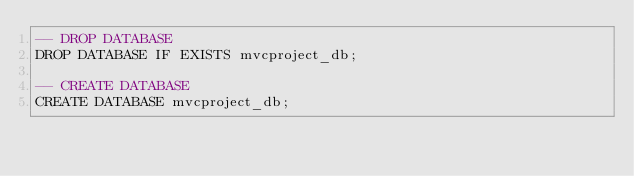<code> <loc_0><loc_0><loc_500><loc_500><_SQL_>-- DROP DATABASE
DROP DATABASE IF EXISTS mvcproject_db;

-- CREATE DATABASE
CREATE DATABASE mvcproject_db;</code> 